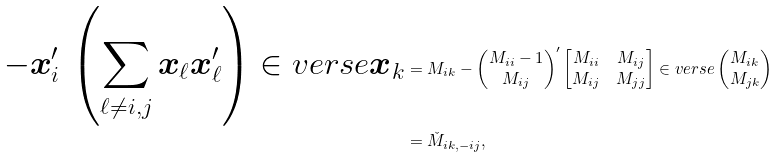Convert formula to latex. <formula><loc_0><loc_0><loc_500><loc_500>- { \boldsymbol x } _ { i } ^ { \prime } \, \left ( \sum _ { \ell \neq i , j } { \boldsymbol x } _ { \ell } { \boldsymbol x } _ { \ell } ^ { \prime } \right ) \in v e r s e { \boldsymbol x } _ { k } & = M _ { i k } - \begin{pmatrix} M _ { i i } - 1 \\ M _ { i j } \end{pmatrix} ^ { \prime } \begin{bmatrix} M _ { i i } & M _ { i j } \\ M _ { i j } & M _ { j j } \end{bmatrix} \in v e r s e \begin{pmatrix} M _ { i k } \\ M _ { j k } \end{pmatrix} \\ & = \check { M } _ { i k , - i j } ,</formula> 